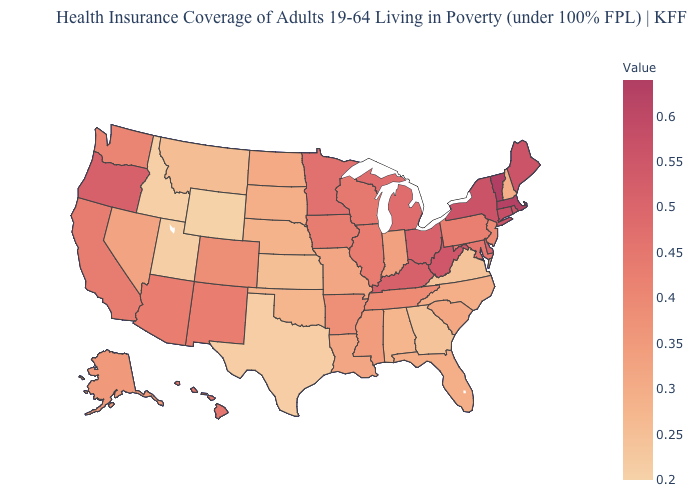Which states have the lowest value in the USA?
Quick response, please. Wyoming. Which states have the lowest value in the USA?
Be succinct. Wyoming. Among the states that border Louisiana , which have the lowest value?
Write a very short answer. Texas. Among the states that border Georgia , does Tennessee have the highest value?
Quick response, please. Yes. Which states have the highest value in the USA?
Write a very short answer. Vermont. Among the states that border Wyoming , does Utah have the highest value?
Quick response, please. No. Which states have the lowest value in the USA?
Be succinct. Wyoming. Among the states that border Montana , which have the lowest value?
Be succinct. Wyoming. 